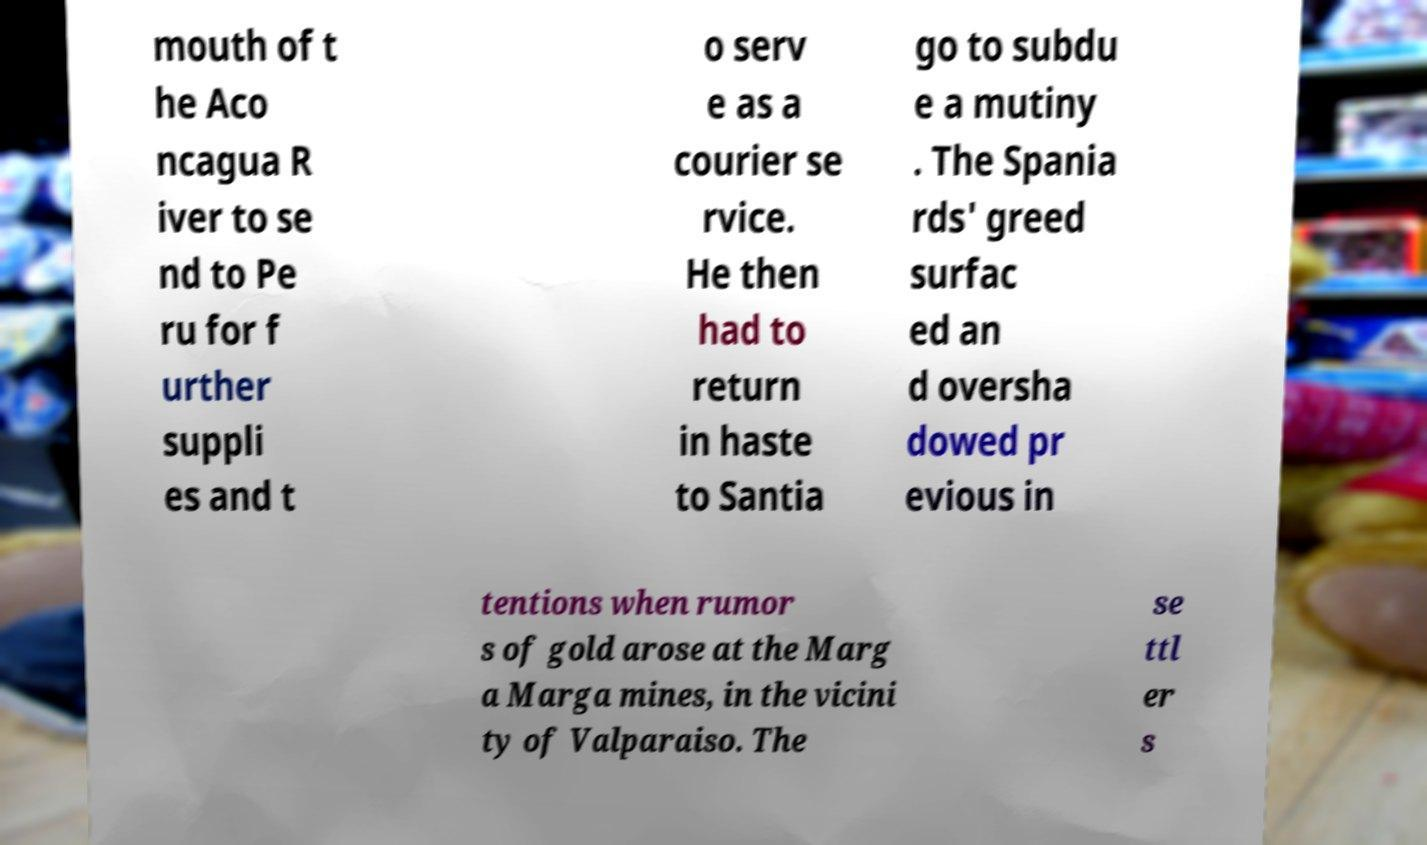There's text embedded in this image that I need extracted. Can you transcribe it verbatim? mouth of t he Aco ncagua R iver to se nd to Pe ru for f urther suppli es and t o serv e as a courier se rvice. He then had to return in haste to Santia go to subdu e a mutiny . The Spania rds' greed surfac ed an d oversha dowed pr evious in tentions when rumor s of gold arose at the Marg a Marga mines, in the vicini ty of Valparaiso. The se ttl er s 